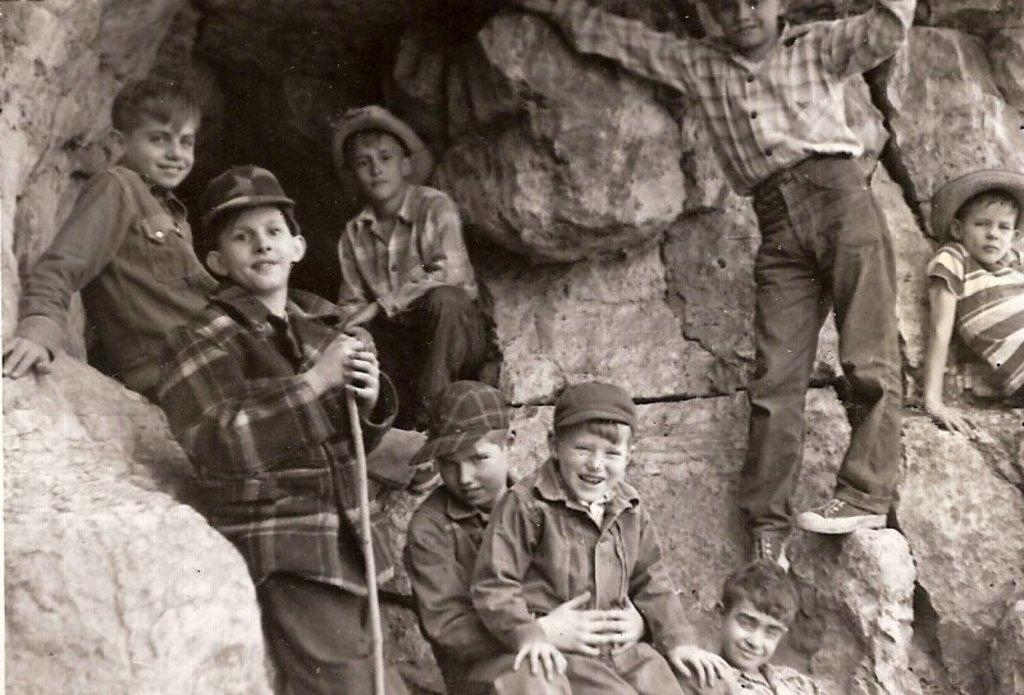What is the color scheme of the image? The image is black and white. Who is present in the image? There are kids in the image. What are the kids doing in the image? The kids are sitting and standing on stones. Are any of the kids wearing any specific clothing items? Some kids are wearing caps. What is one kid holding in the image? One kid is holding a stick. What type of birds can be seen flying in the image? There are no birds present in the image; it features kids sitting and standing on stones. 